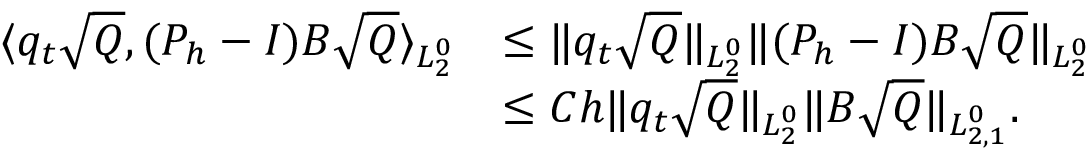Convert formula to latex. <formula><loc_0><loc_0><loc_500><loc_500>\begin{array} { r l } { \langle q _ { t } \sqrt { Q } , ( P _ { h } - I ) B \sqrt { Q } \rangle _ { L _ { 2 } ^ { 0 } } } & { \leq \| q _ { t } \sqrt { Q } \| _ { L _ { 2 } ^ { 0 } } \| ( P _ { h } - I ) B \sqrt { Q } \| _ { L _ { 2 } ^ { 0 } } } \\ & { \leq C h \| q _ { t } \sqrt { Q } \| _ { L _ { 2 } ^ { 0 } } \| B \sqrt { Q } \| _ { L _ { 2 , 1 } ^ { 0 } } . } \end{array}</formula> 